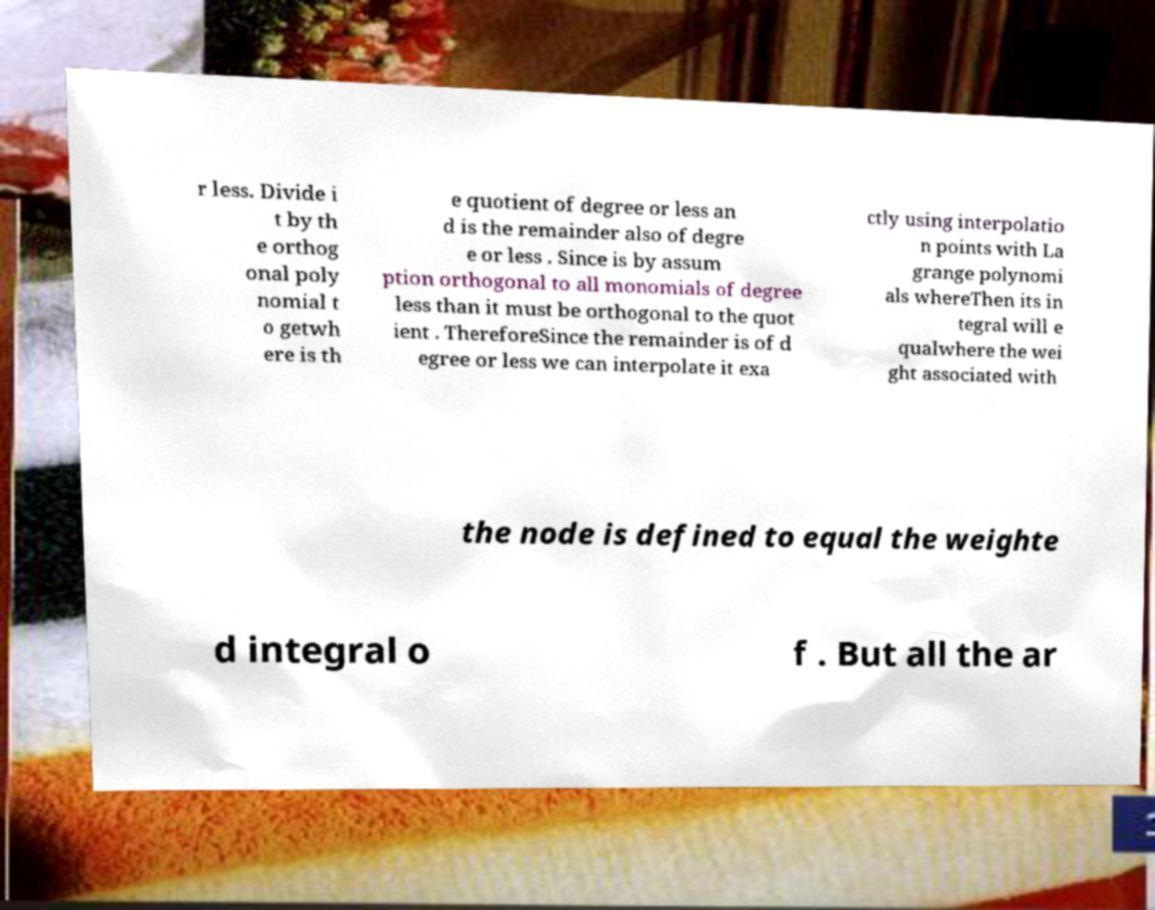What messages or text are displayed in this image? I need them in a readable, typed format. r less. Divide i t by th e orthog onal poly nomial t o getwh ere is th e quotient of degree or less an d is the remainder also of degre e or less . Since is by assum ption orthogonal to all monomials of degree less than it must be orthogonal to the quot ient . ThereforeSince the remainder is of d egree or less we can interpolate it exa ctly using interpolatio n points with La grange polynomi als whereThen its in tegral will e qualwhere the wei ght associated with the node is defined to equal the weighte d integral o f . But all the ar 